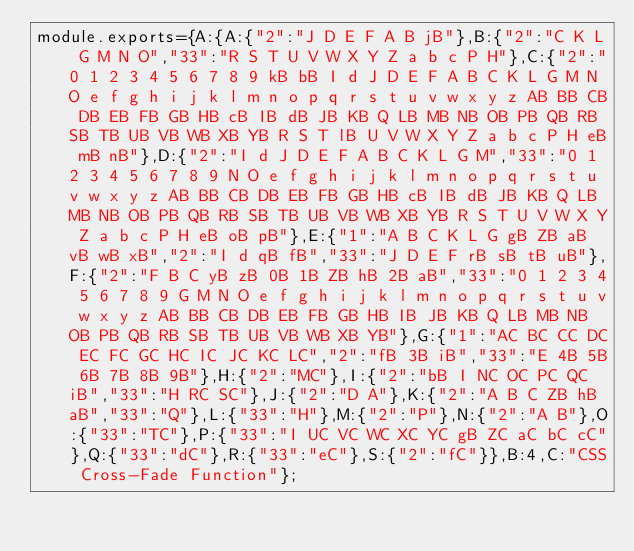<code> <loc_0><loc_0><loc_500><loc_500><_JavaScript_>module.exports={A:{A:{"2":"J D E F A B jB"},B:{"2":"C K L G M N O","33":"R S T U V W X Y Z a b c P H"},C:{"2":"0 1 2 3 4 5 6 7 8 9 kB bB I d J D E F A B C K L G M N O e f g h i j k l m n o p q r s t u v w x y z AB BB CB DB EB FB GB HB cB IB dB JB KB Q LB MB NB OB PB QB RB SB TB UB VB WB XB YB R S T lB U V W X Y Z a b c P H eB mB nB"},D:{"2":"I d J D E F A B C K L G M","33":"0 1 2 3 4 5 6 7 8 9 N O e f g h i j k l m n o p q r s t u v w x y z AB BB CB DB EB FB GB HB cB IB dB JB KB Q LB MB NB OB PB QB RB SB TB UB VB WB XB YB R S T U V W X Y Z a b c P H eB oB pB"},E:{"1":"A B C K L G gB ZB aB vB wB xB","2":"I d qB fB","33":"J D E F rB sB tB uB"},F:{"2":"F B C yB zB 0B 1B ZB hB 2B aB","33":"0 1 2 3 4 5 6 7 8 9 G M N O e f g h i j k l m n o p q r s t u v w x y z AB BB CB DB EB FB GB HB IB JB KB Q LB MB NB OB PB QB RB SB TB UB VB WB XB YB"},G:{"1":"AC BC CC DC EC FC GC HC IC JC KC LC","2":"fB 3B iB","33":"E 4B 5B 6B 7B 8B 9B"},H:{"2":"MC"},I:{"2":"bB I NC OC PC QC iB","33":"H RC SC"},J:{"2":"D A"},K:{"2":"A B C ZB hB aB","33":"Q"},L:{"33":"H"},M:{"2":"P"},N:{"2":"A B"},O:{"33":"TC"},P:{"33":"I UC VC WC XC YC gB ZC aC bC cC"},Q:{"33":"dC"},R:{"33":"eC"},S:{"2":"fC"}},B:4,C:"CSS Cross-Fade Function"};
</code> 